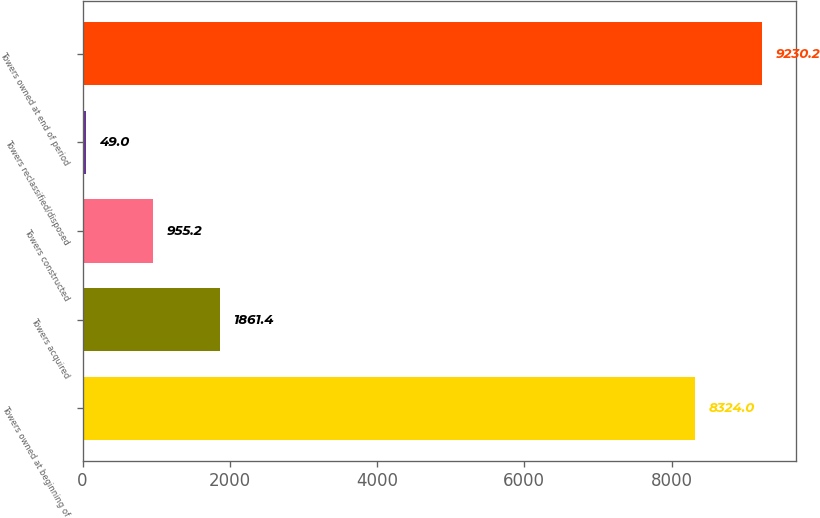Convert chart. <chart><loc_0><loc_0><loc_500><loc_500><bar_chart><fcel>Towers owned at beginning of<fcel>Towers acquired<fcel>Towers constructed<fcel>Towers reclassified/disposed<fcel>Towers owned at end of period<nl><fcel>8324<fcel>1861.4<fcel>955.2<fcel>49<fcel>9230.2<nl></chart> 